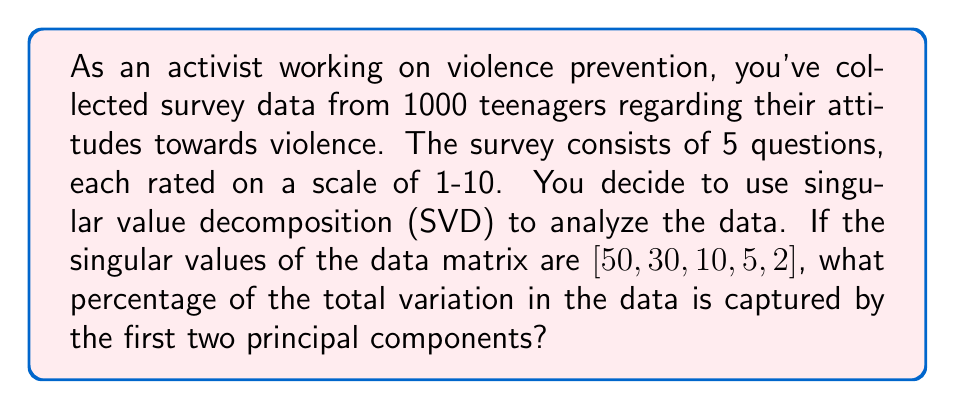Could you help me with this problem? Let's approach this step-by-step:

1) In SVD, the singular values represent the square roots of the eigenvalues of the covariance matrix. They indicate the amount of variation captured by each principal component.

2) To find the total variation, we need to sum the squares of all singular values:

   $$\text{Total variation} = 50^2 + 30^2 + 10^2 + 5^2 + 2^2 = 3629$$

3) The variation captured by the first two principal components is the sum of the squares of the first two singular values:

   $$\text{Variation of first two PCs} = 50^2 + 30^2 = 3400$$

4) To calculate the percentage, we divide the variation of the first two PCs by the total variation and multiply by 100:

   $$\text{Percentage} = \frac{3400}{3629} \times 100 \approx 93.69\%$$

5) Rounding to two decimal places, we get 93.69%.

This high percentage indicates that the first two principal components capture most of the variation in the teenagers' attitudes towards violence, which could be valuable for focusing violence prevention efforts.
Answer: 93.69% 